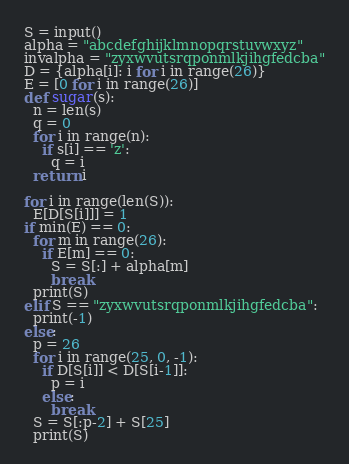Convert code to text. <code><loc_0><loc_0><loc_500><loc_500><_Python_>S = input()
alpha = "abcdefghijklmnopqrstuvwxyz"
invalpha = "zyxwvutsrqponmlkjihgfedcba"
D = {alpha[i]: i for i in range(26)}
E = [0 for i in range(26)]
def sugar(s):
  n = len(s)
  q = 0
  for i in range(n):
    if s[i] == 'z':
      q = i
  return i

for i in range(len(S)):
  E[D[S[i]]] = 1
if min(E) == 0:
  for m in range(26):
    if E[m] == 0:
      S = S[:] + alpha[m]
      break
  print(S)
elif S == "zyxwvutsrqponmlkjihgfedcba":
  print(-1)
else:
  p = 26
  for i in range(25, 0, -1):
    if D[S[i]] < D[S[i-1]]:
      p = i
    else:
      break
  S = S[:p-2] + S[25]
  print(S)</code> 